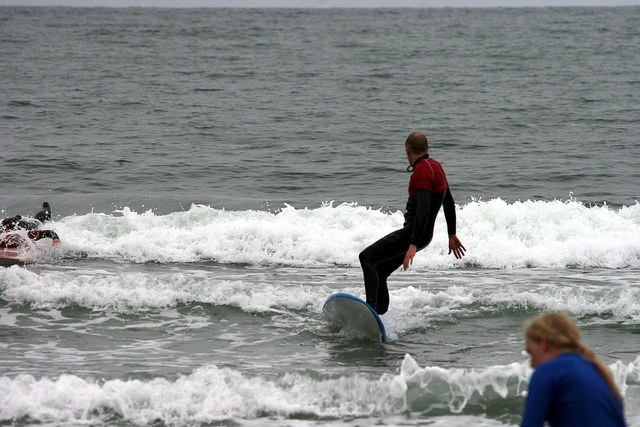Describe the objects in this image and their specific colors. I can see people in darkgray, black, white, and maroon tones, people in darkgray, navy, black, and maroon tones, people in darkgray, black, gray, and lightgray tones, surfboard in darkgray, gray, and black tones, and surfboard in darkgray, black, gray, and lightgray tones in this image. 